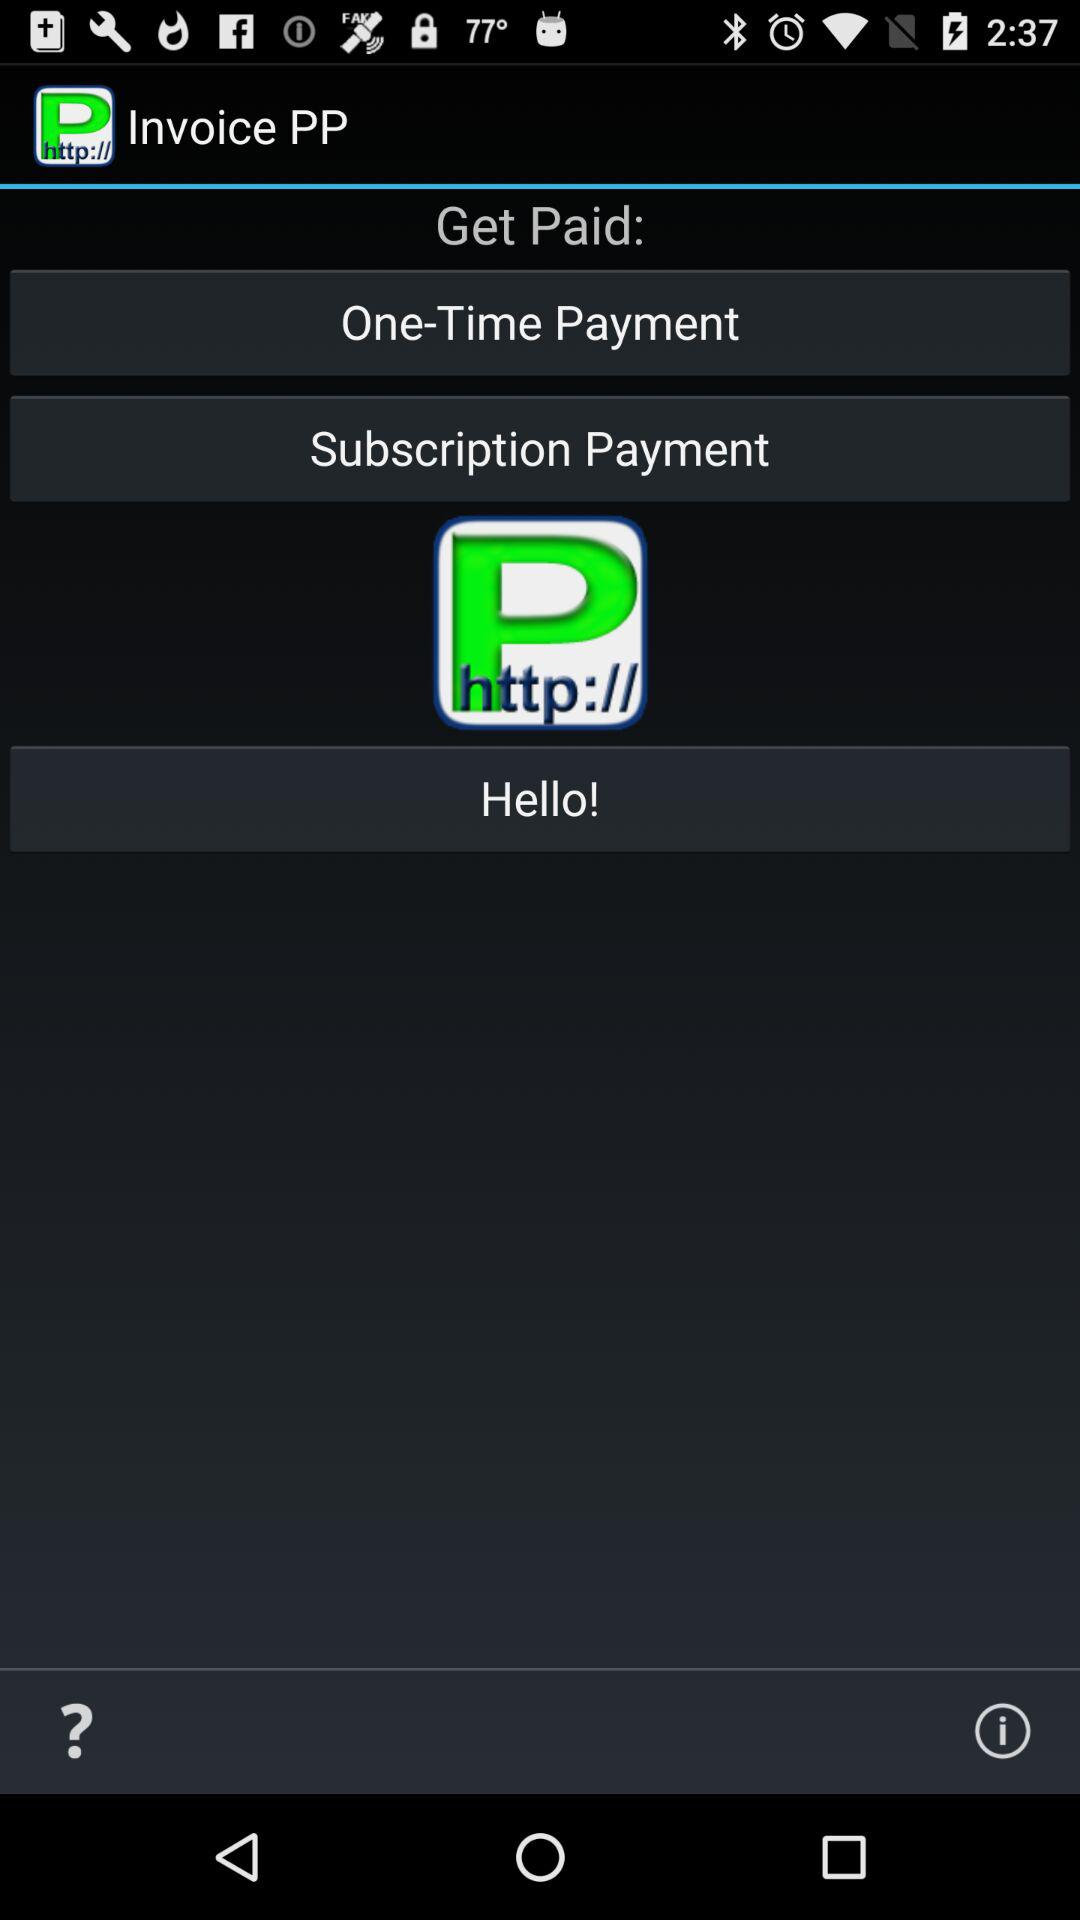What is the name of the application? The name of the application is "Invoice PP". 